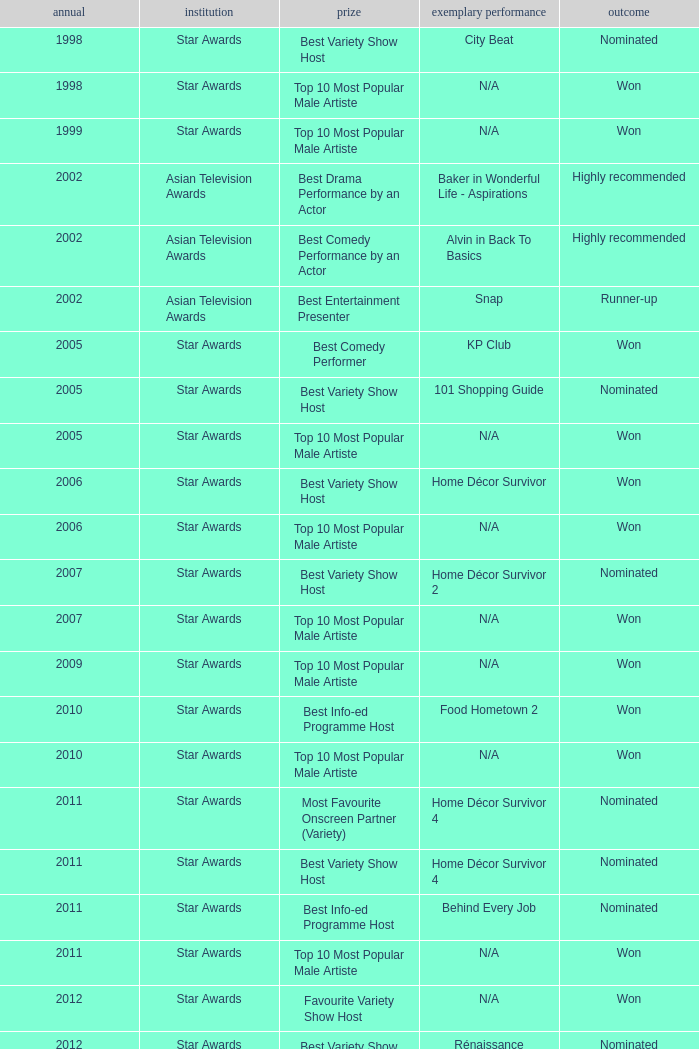What is the name of the award in a year more than 2005, and the Result of nominated? Best Variety Show Host, Most Favourite Onscreen Partner (Variety), Best Variety Show Host, Best Info-ed Programme Host, Best Variety Show Host, Best Info-ed Programme Host, Best Info-Ed Programme Host, Best Variety Show Host. 